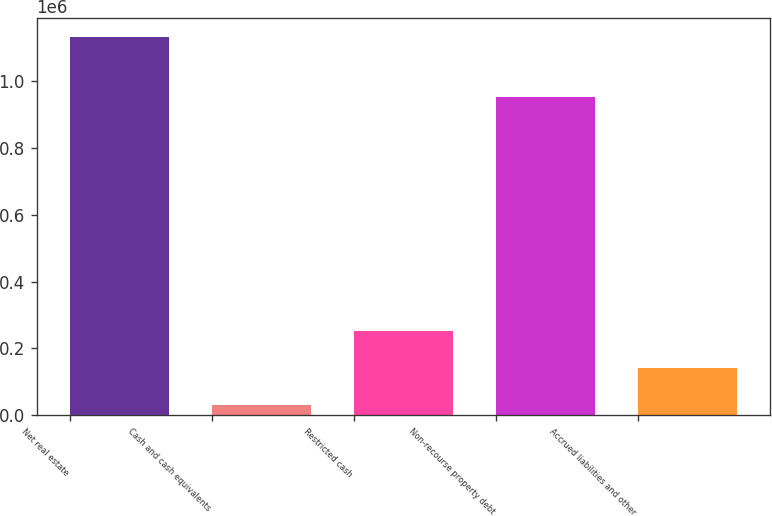Convert chart. <chart><loc_0><loc_0><loc_500><loc_500><bar_chart><fcel>Net real estate<fcel>Cash and cash equivalents<fcel>Restricted cash<fcel>Non-recourse property debt<fcel>Accrued liabilities and other<nl><fcel>1.13343e+06<fcel>30803<fcel>251328<fcel>954571<fcel>141066<nl></chart> 